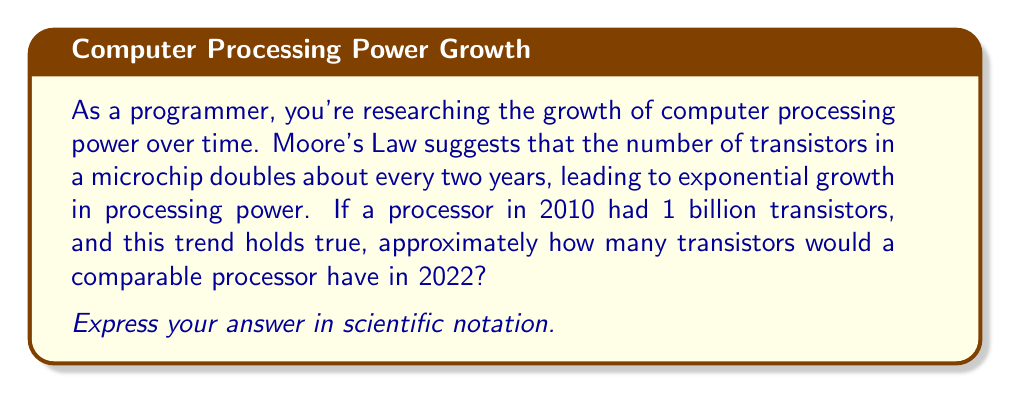Show me your answer to this math problem. Let's approach this step-by-step:

1) First, we need to determine how many 2-year periods have passed from 2010 to 2022:
   $$(2022 - 2010) \div 2 = 12 \div 2 = 6$$ periods

2) Now, we can set up our exponential growth equation:
   $$T = 1 \times 2^n$$
   Where:
   $T$ = number of transistors after $n$ periods
   $1$ = initial number of transistors (in billions)
   $2$ = growth factor (doubles every period)
   $n$ = number of periods (6)

3) Let's substitute our values:
   $$T = 1 \times 2^6$$

4) Calculate:
   $$\begin{align}
   T &= 1 \times 2^6 \\
   &= 1 \times 64 \\
   &= 64 \text{ billion transistors}
   \end{align}$$

5) Convert to scientific notation:
   $$64 \text{ billion} = 64 \times 10^9$$

Therefore, a comparable processor in 2022 would have approximately $64 \times 10^9$ transistors.
Answer: $6.4 \times 10^{10}$ transistors 